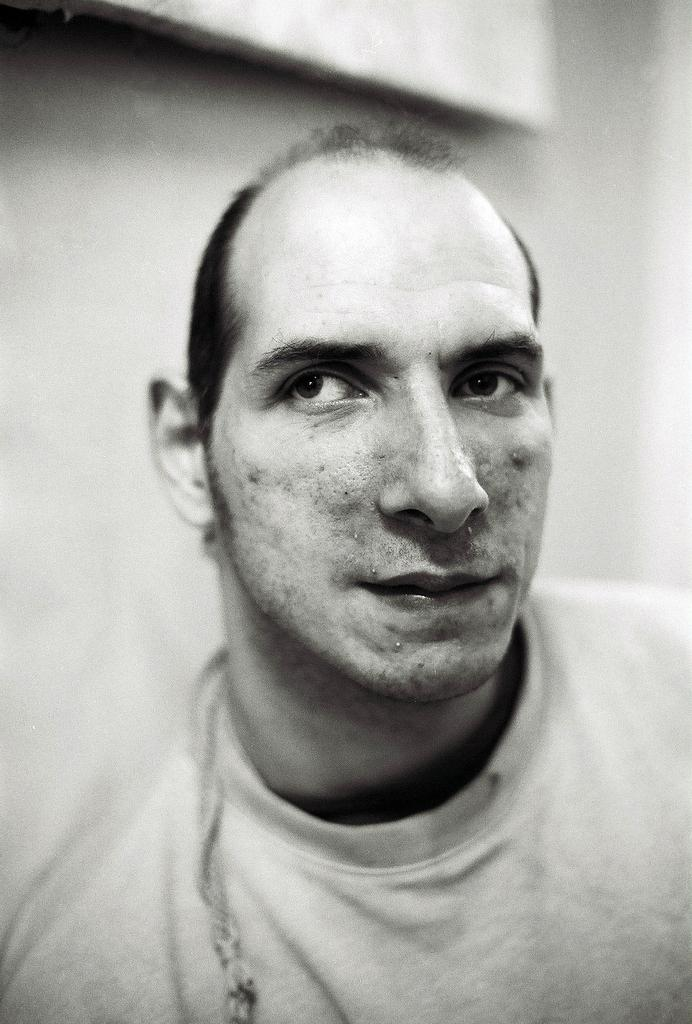What is the main subject of the image? There is a man in the center of the image. Can you describe the background of the image? There is a wall in the background of the image. What color is the man's toe in the image? There is no specific detail about the man's toe provided in the image, so it cannot be determined. What is the man's brain doing in the image? There is no information about the man's brain in the image, as it is not visible. 